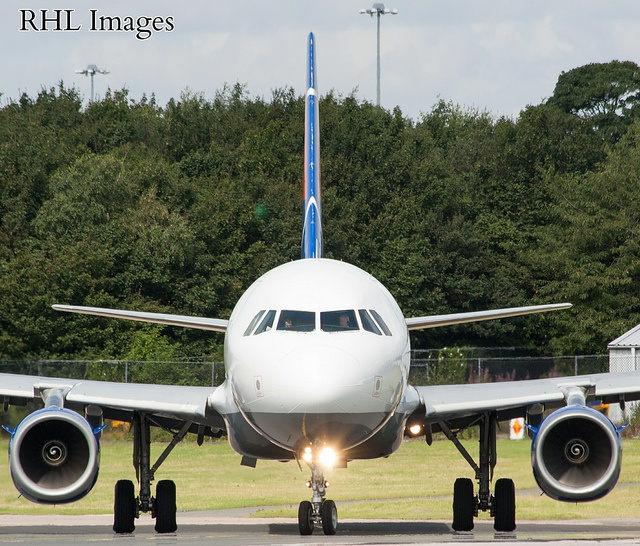Describe the objects in this image and their specific colors. I can see airplane in lightgray, black, gray, and darkgray tones, people in lightgray, gray, blue, darkblue, and black tones, and people in lightgray, gray, purple, and darkgray tones in this image. 